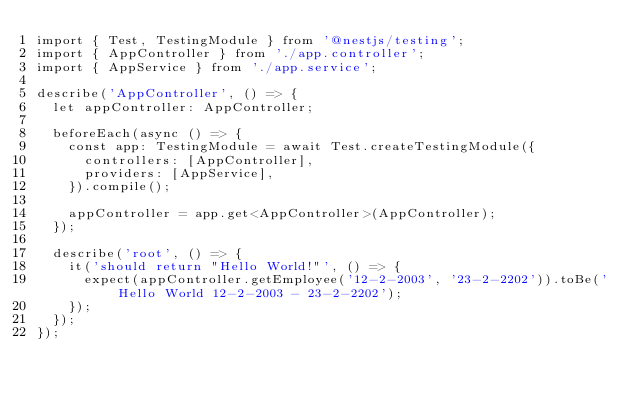<code> <loc_0><loc_0><loc_500><loc_500><_TypeScript_>import { Test, TestingModule } from '@nestjs/testing';
import { AppController } from './app.controller';
import { AppService } from './app.service';

describe('AppController', () => {
  let appController: AppController;

  beforeEach(async () => {
    const app: TestingModule = await Test.createTestingModule({
      controllers: [AppController],
      providers: [AppService],
    }).compile();

    appController = app.get<AppController>(AppController);
  });

  describe('root', () => {
    it('should return "Hello World!"', () => {
      expect(appController.getEmployee('12-2-2003', '23-2-2202')).toBe('Hello World 12-2-2003 - 23-2-2202');
    });
  });
});
</code> 